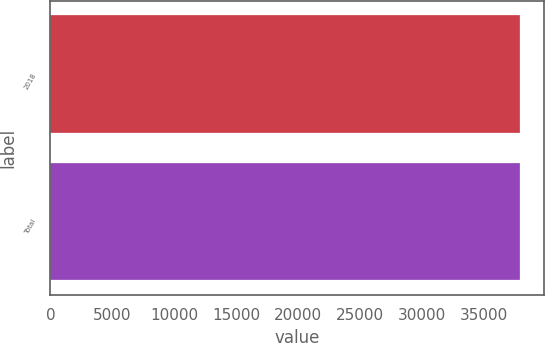Convert chart. <chart><loc_0><loc_0><loc_500><loc_500><bar_chart><fcel>2018<fcel>Total<nl><fcel>37959<fcel>37959.1<nl></chart> 